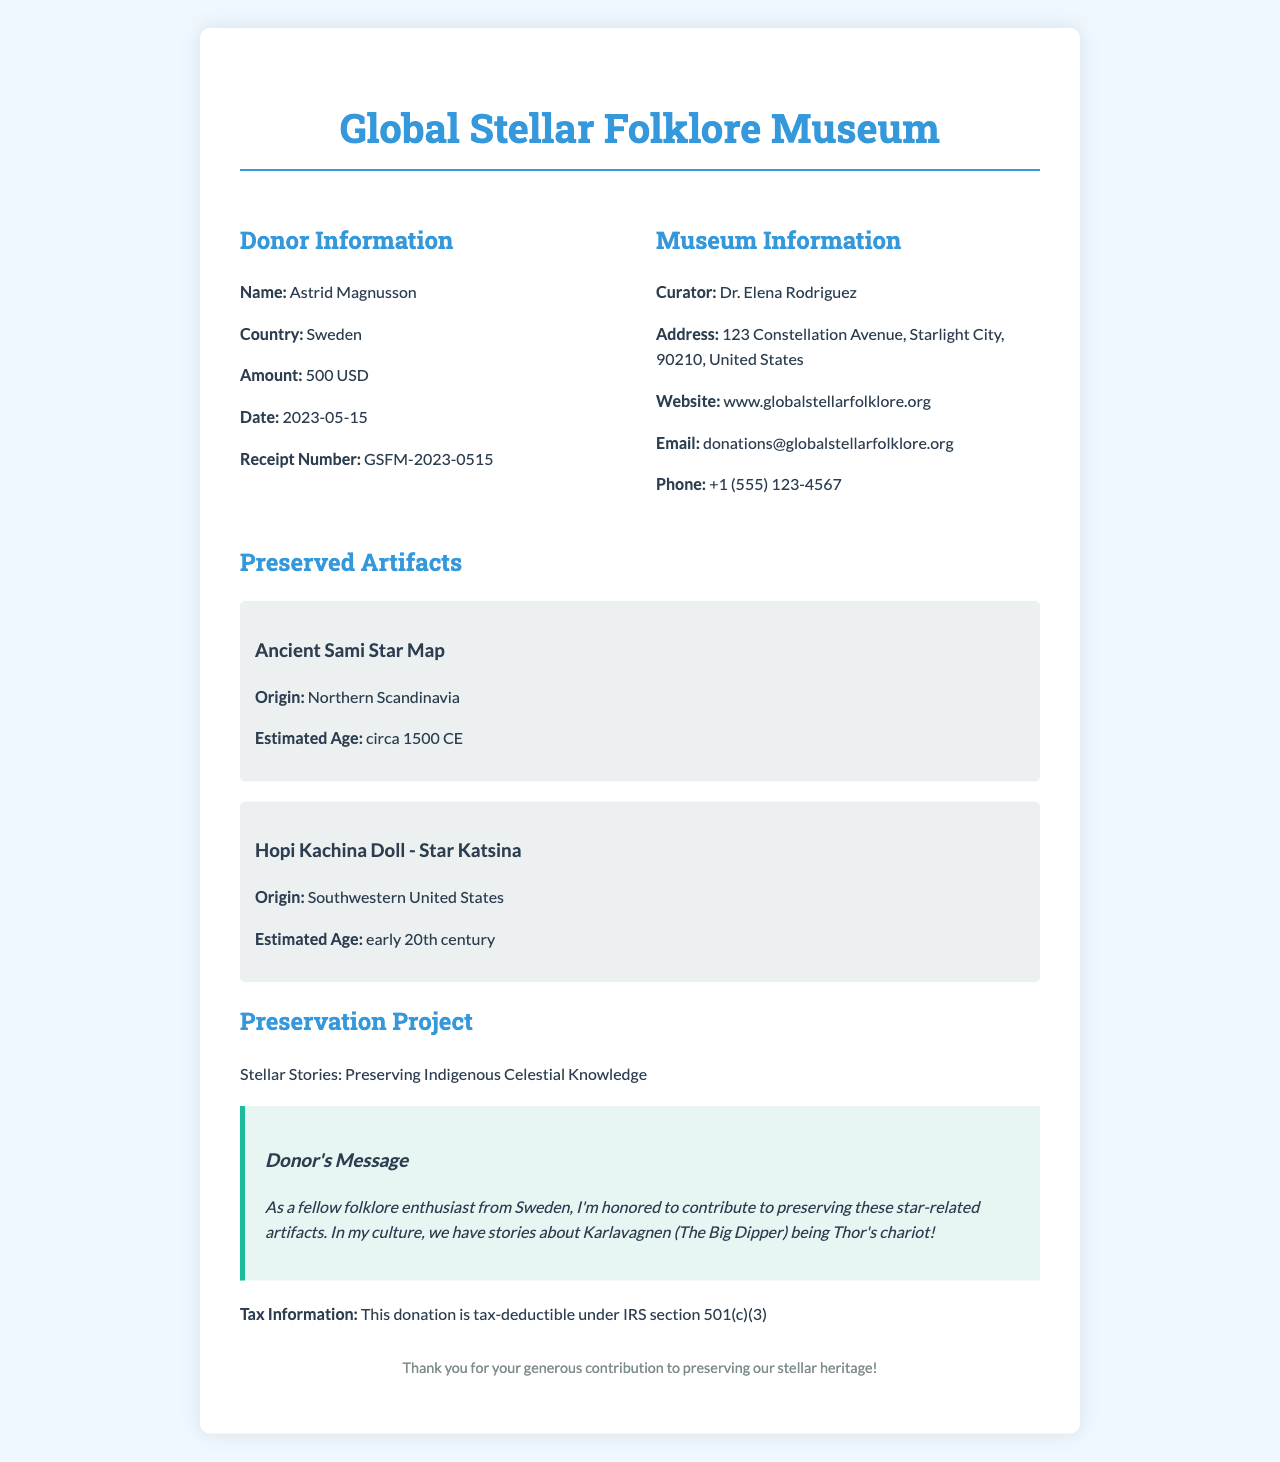what is the name of the museum? The name of the museum is listed at the top of the receipt as the organization that issued it.
Answer: Global Stellar Folklore Museum who is the donor? The donor's name is provided in the donor information section of the receipt.
Answer: Astrid Magnusson what is the donation amount? The donation amount is specified in the donor information section.
Answer: 500 USD when was the donation made? The date of the donation is mentioned in the receipt details.
Answer: 2023-05-15 what is the preservation project called? The title of the preservation project is given in the document.
Answer: Stellar Stories: Preserving Indigenous Celestial Knowledge how many artifacts are listed in the document? The document contains a section titled "Preserved Artifacts" that details multiple items.
Answer: 2 what is the origin of the Ancient Sami Star Map? The origin of each artifact is provided under their respective details in the document.
Answer: Northern Scandinavia which country's folklore does the donor reference in their message? The donor's country is noted in their message and in the donor information section.
Answer: Sweden is the donation tax-deductible? The document specifically states whether or not the donation is eligible for tax deduction.
Answer: Yes 